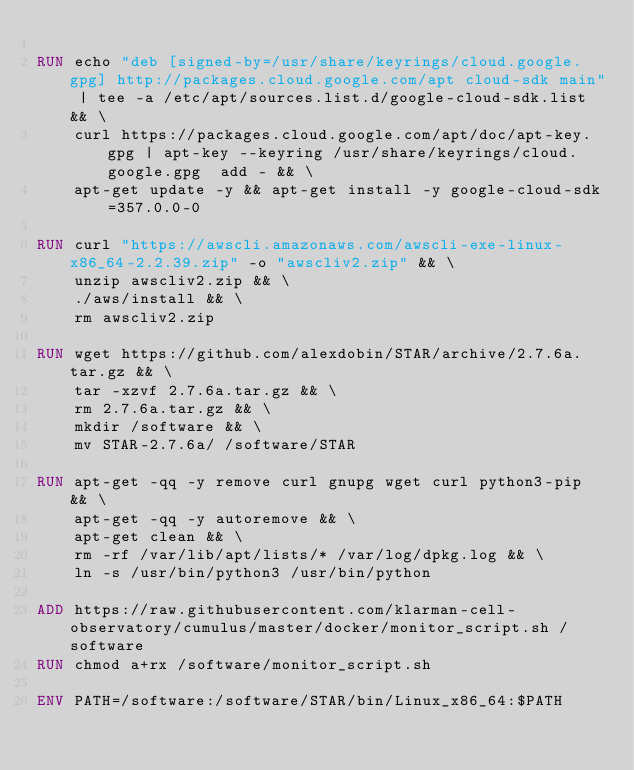Convert code to text. <code><loc_0><loc_0><loc_500><loc_500><_Dockerfile_>
RUN echo "deb [signed-by=/usr/share/keyrings/cloud.google.gpg] http://packages.cloud.google.com/apt cloud-sdk main" | tee -a /etc/apt/sources.list.d/google-cloud-sdk.list && \
    curl https://packages.cloud.google.com/apt/doc/apt-key.gpg | apt-key --keyring /usr/share/keyrings/cloud.google.gpg  add - && \
    apt-get update -y && apt-get install -y google-cloud-sdk=357.0.0-0

RUN curl "https://awscli.amazonaws.com/awscli-exe-linux-x86_64-2.2.39.zip" -o "awscliv2.zip" && \
    unzip awscliv2.zip && \
    ./aws/install && \
    rm awscliv2.zip

RUN wget https://github.com/alexdobin/STAR/archive/2.7.6a.tar.gz && \
    tar -xzvf 2.7.6a.tar.gz && \
    rm 2.7.6a.tar.gz && \
    mkdir /software && \
    mv STAR-2.7.6a/ /software/STAR

RUN apt-get -qq -y remove curl gnupg wget curl python3-pip && \
    apt-get -qq -y autoremove && \
    apt-get clean && \
    rm -rf /var/lib/apt/lists/* /var/log/dpkg.log && \
    ln -s /usr/bin/python3 /usr/bin/python

ADD https://raw.githubusercontent.com/klarman-cell-observatory/cumulus/master/docker/monitor_script.sh /software
RUN chmod a+rx /software/monitor_script.sh

ENV PATH=/software:/software/STAR/bin/Linux_x86_64:$PATH
</code> 